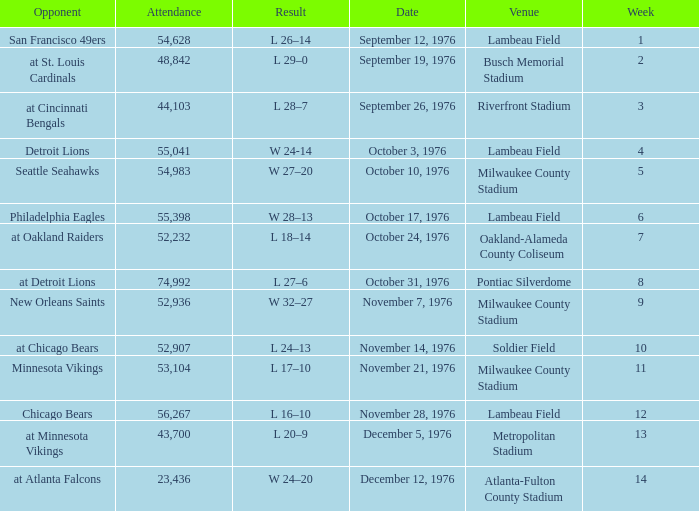How many people attended the game on September 19, 1976? 1.0. 